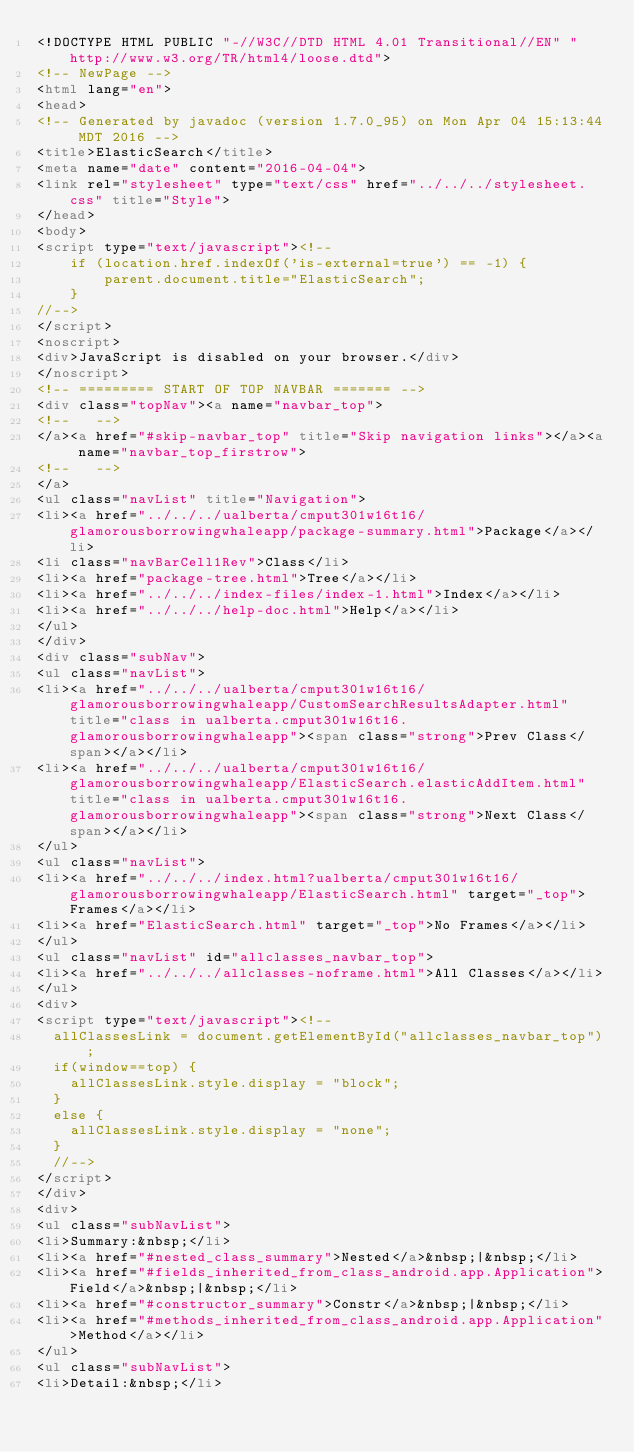<code> <loc_0><loc_0><loc_500><loc_500><_HTML_><!DOCTYPE HTML PUBLIC "-//W3C//DTD HTML 4.01 Transitional//EN" "http://www.w3.org/TR/html4/loose.dtd">
<!-- NewPage -->
<html lang="en">
<head>
<!-- Generated by javadoc (version 1.7.0_95) on Mon Apr 04 15:13:44 MDT 2016 -->
<title>ElasticSearch</title>
<meta name="date" content="2016-04-04">
<link rel="stylesheet" type="text/css" href="../../../stylesheet.css" title="Style">
</head>
<body>
<script type="text/javascript"><!--
    if (location.href.indexOf('is-external=true') == -1) {
        parent.document.title="ElasticSearch";
    }
//-->
</script>
<noscript>
<div>JavaScript is disabled on your browser.</div>
</noscript>
<!-- ========= START OF TOP NAVBAR ======= -->
<div class="topNav"><a name="navbar_top">
<!--   -->
</a><a href="#skip-navbar_top" title="Skip navigation links"></a><a name="navbar_top_firstrow">
<!--   -->
</a>
<ul class="navList" title="Navigation">
<li><a href="../../../ualberta/cmput301w16t16/glamorousborrowingwhaleapp/package-summary.html">Package</a></li>
<li class="navBarCell1Rev">Class</li>
<li><a href="package-tree.html">Tree</a></li>
<li><a href="../../../index-files/index-1.html">Index</a></li>
<li><a href="../../../help-doc.html">Help</a></li>
</ul>
</div>
<div class="subNav">
<ul class="navList">
<li><a href="../../../ualberta/cmput301w16t16/glamorousborrowingwhaleapp/CustomSearchResultsAdapter.html" title="class in ualberta.cmput301w16t16.glamorousborrowingwhaleapp"><span class="strong">Prev Class</span></a></li>
<li><a href="../../../ualberta/cmput301w16t16/glamorousborrowingwhaleapp/ElasticSearch.elasticAddItem.html" title="class in ualberta.cmput301w16t16.glamorousborrowingwhaleapp"><span class="strong">Next Class</span></a></li>
</ul>
<ul class="navList">
<li><a href="../../../index.html?ualberta/cmput301w16t16/glamorousborrowingwhaleapp/ElasticSearch.html" target="_top">Frames</a></li>
<li><a href="ElasticSearch.html" target="_top">No Frames</a></li>
</ul>
<ul class="navList" id="allclasses_navbar_top">
<li><a href="../../../allclasses-noframe.html">All Classes</a></li>
</ul>
<div>
<script type="text/javascript"><!--
  allClassesLink = document.getElementById("allclasses_navbar_top");
  if(window==top) {
    allClassesLink.style.display = "block";
  }
  else {
    allClassesLink.style.display = "none";
  }
  //-->
</script>
</div>
<div>
<ul class="subNavList">
<li>Summary:&nbsp;</li>
<li><a href="#nested_class_summary">Nested</a>&nbsp;|&nbsp;</li>
<li><a href="#fields_inherited_from_class_android.app.Application">Field</a>&nbsp;|&nbsp;</li>
<li><a href="#constructor_summary">Constr</a>&nbsp;|&nbsp;</li>
<li><a href="#methods_inherited_from_class_android.app.Application">Method</a></li>
</ul>
<ul class="subNavList">
<li>Detail:&nbsp;</li></code> 